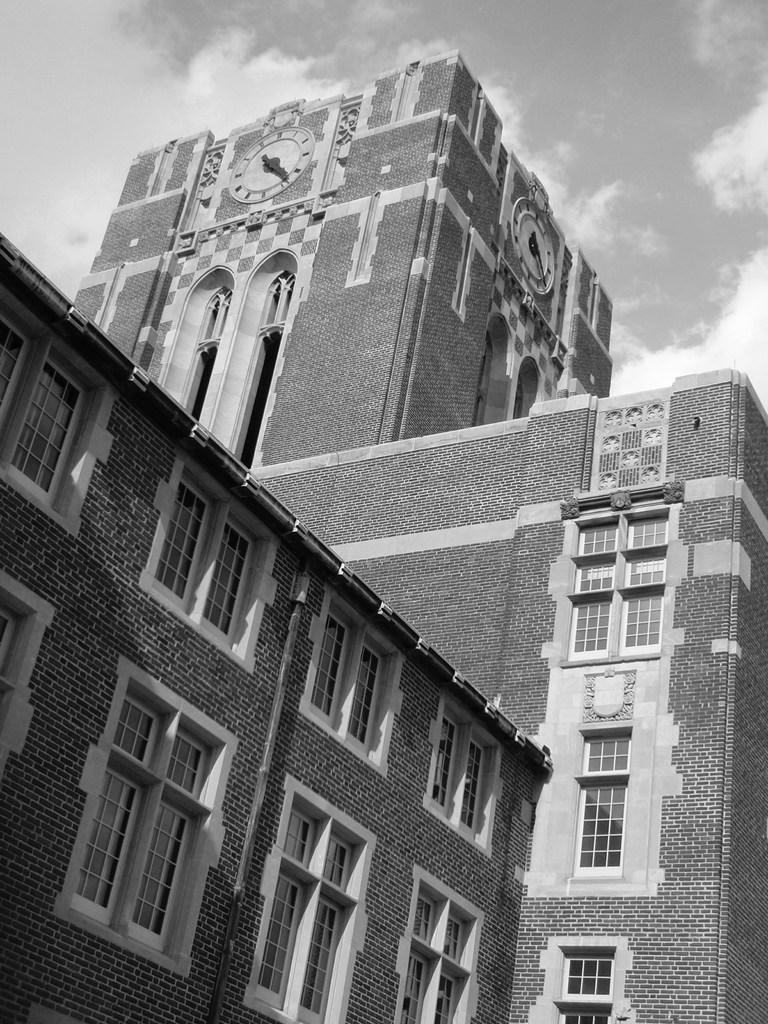What is present on the building in the image? There are clocks on the building in the image. What can be seen in the sky in the image? There are clouds visible in the image. Where is the zebra located in the image? There is no zebra present in the image. What type of cat can be seen playing with the clocks on the building? There is no cat present in the image, and the clocks are not depicted as being played with. 